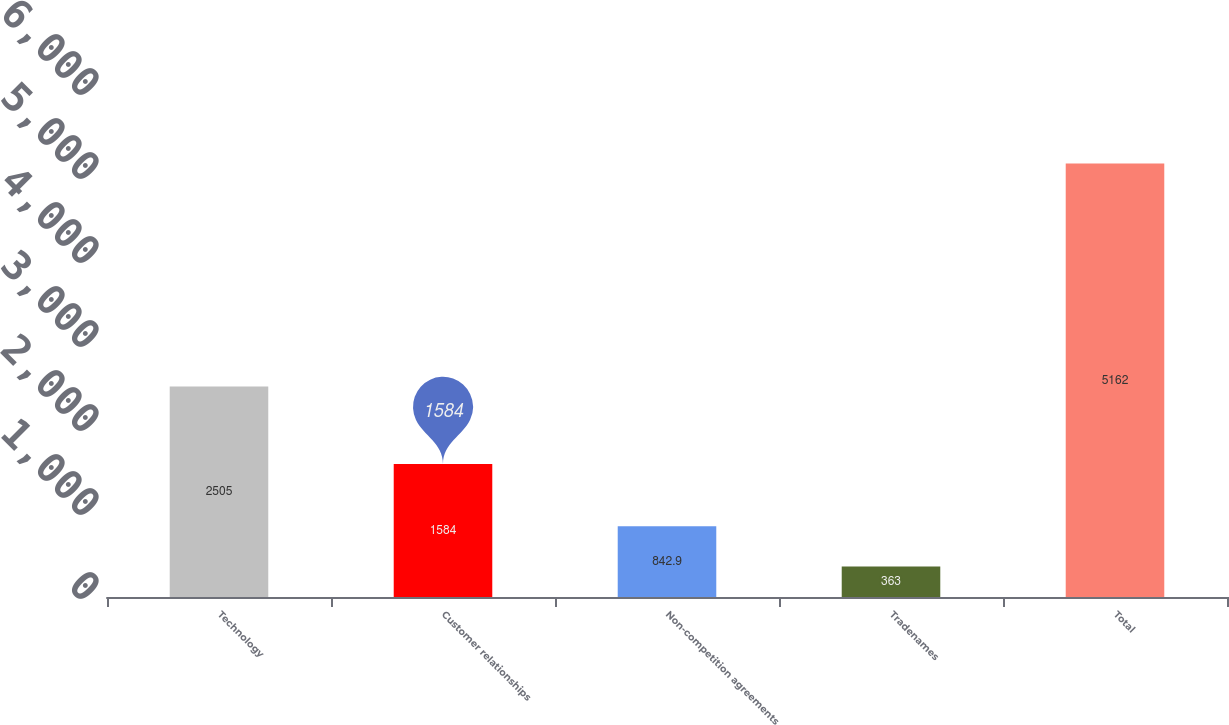Convert chart to OTSL. <chart><loc_0><loc_0><loc_500><loc_500><bar_chart><fcel>Technology<fcel>Customer relationships<fcel>Non-competition agreements<fcel>Tradenames<fcel>Total<nl><fcel>2505<fcel>1584<fcel>842.9<fcel>363<fcel>5162<nl></chart> 